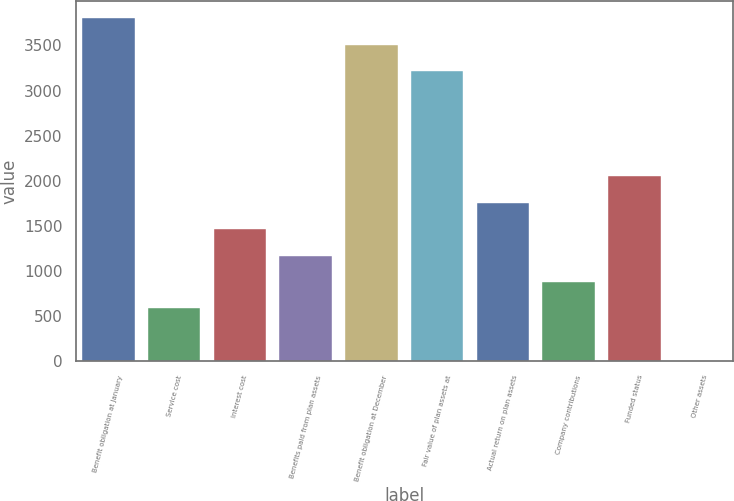Convert chart. <chart><loc_0><loc_0><loc_500><loc_500><bar_chart><fcel>Benefit obligation at January<fcel>Service cost<fcel>Interest cost<fcel>Benefits paid from plan assets<fcel>Benefit obligation at December<fcel>Fair value of plan assets at<fcel>Actual return on plan assets<fcel>Company contributions<fcel>Funded status<fcel>Other assets<nl><fcel>3800.3<fcel>587.2<fcel>1463.5<fcel>1171.4<fcel>3508.2<fcel>3216.1<fcel>1755.6<fcel>879.3<fcel>2047.7<fcel>3<nl></chart> 